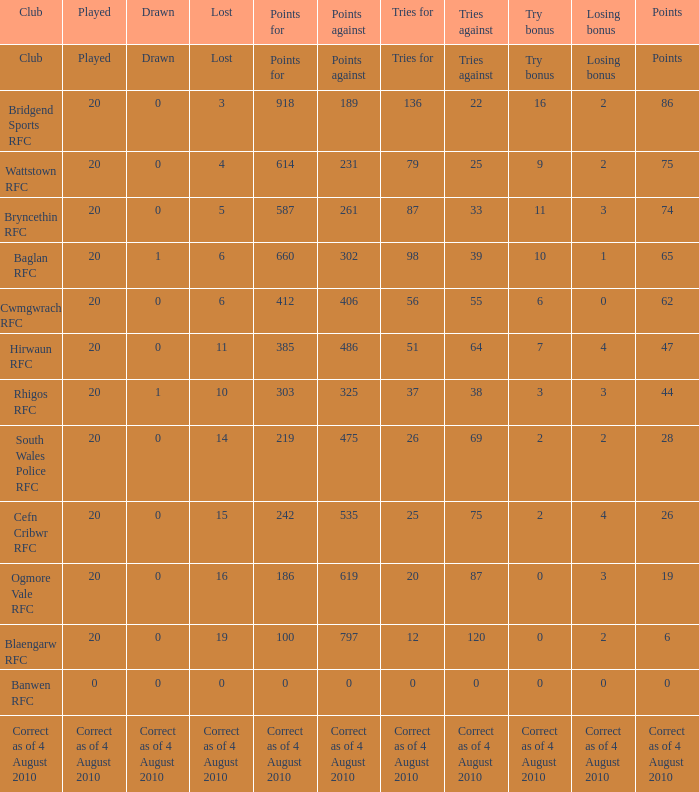What is absent when the points against amount to 231? 4.0. 